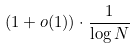<formula> <loc_0><loc_0><loc_500><loc_500>( 1 + o ( 1 ) ) \cdot \frac { 1 } { \log N }</formula> 